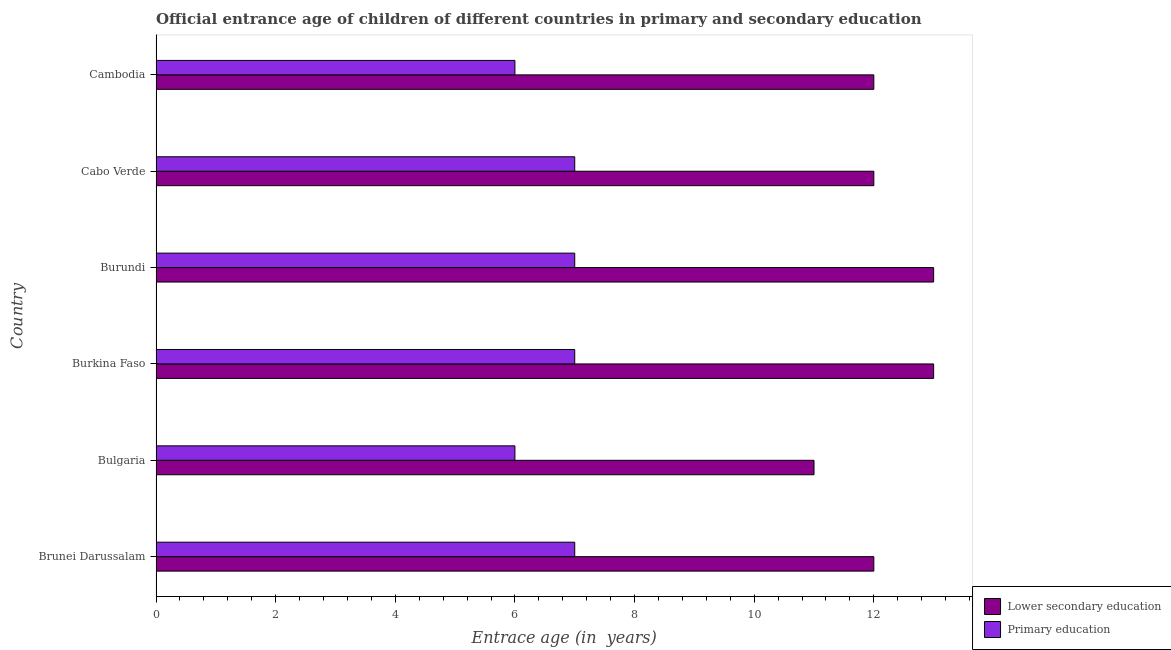How many groups of bars are there?
Ensure brevity in your answer.  6. Are the number of bars on each tick of the Y-axis equal?
Provide a short and direct response. Yes. How many bars are there on the 2nd tick from the bottom?
Offer a very short reply. 2. What is the label of the 3rd group of bars from the top?
Your response must be concise. Burundi. What is the entrance age of children in lower secondary education in Cabo Verde?
Your answer should be compact. 12. Across all countries, what is the maximum entrance age of chiildren in primary education?
Make the answer very short. 7. In which country was the entrance age of children in lower secondary education maximum?
Ensure brevity in your answer.  Burkina Faso. In which country was the entrance age of children in lower secondary education minimum?
Offer a terse response. Bulgaria. What is the total entrance age of children in lower secondary education in the graph?
Provide a short and direct response. 73. What is the difference between the entrance age of children in lower secondary education in Burundi and the entrance age of chiildren in primary education in Brunei Darussalam?
Provide a short and direct response. 6. What is the average entrance age of chiildren in primary education per country?
Keep it short and to the point. 6.67. What is the ratio of the entrance age of chiildren in primary education in Burkina Faso to that in Cambodia?
Provide a succinct answer. 1.17. Is the entrance age of children in lower secondary education in Burkina Faso less than that in Cabo Verde?
Give a very brief answer. No. Is the difference between the entrance age of chiildren in primary education in Burundi and Cabo Verde greater than the difference between the entrance age of children in lower secondary education in Burundi and Cabo Verde?
Your answer should be very brief. No. What is the difference between the highest and the lowest entrance age of chiildren in primary education?
Provide a succinct answer. 1. Is the sum of the entrance age of chiildren in primary education in Brunei Darussalam and Bulgaria greater than the maximum entrance age of children in lower secondary education across all countries?
Your answer should be very brief. No. What does the 1st bar from the bottom in Cambodia represents?
Keep it short and to the point. Lower secondary education. Are all the bars in the graph horizontal?
Ensure brevity in your answer.  Yes. Where does the legend appear in the graph?
Give a very brief answer. Bottom right. What is the title of the graph?
Keep it short and to the point. Official entrance age of children of different countries in primary and secondary education. Does "Non-solid fuel" appear as one of the legend labels in the graph?
Offer a terse response. No. What is the label or title of the X-axis?
Provide a short and direct response. Entrace age (in  years). What is the Entrace age (in  years) of Primary education in Brunei Darussalam?
Provide a short and direct response. 7. What is the Entrace age (in  years) of Lower secondary education in Burundi?
Make the answer very short. 13. What is the Entrace age (in  years) of Primary education in Burundi?
Ensure brevity in your answer.  7. What is the Entrace age (in  years) of Lower secondary education in Cabo Verde?
Offer a very short reply. 12. What is the Entrace age (in  years) of Primary education in Cabo Verde?
Offer a very short reply. 7. What is the Entrace age (in  years) in Lower secondary education in Cambodia?
Provide a succinct answer. 12. What is the Entrace age (in  years) in Primary education in Cambodia?
Provide a short and direct response. 6. Across all countries, what is the minimum Entrace age (in  years) of Lower secondary education?
Keep it short and to the point. 11. Across all countries, what is the minimum Entrace age (in  years) in Primary education?
Your answer should be very brief. 6. What is the total Entrace age (in  years) in Primary education in the graph?
Provide a succinct answer. 40. What is the difference between the Entrace age (in  years) of Lower secondary education in Brunei Darussalam and that in Burkina Faso?
Your answer should be compact. -1. What is the difference between the Entrace age (in  years) in Lower secondary education in Brunei Darussalam and that in Burundi?
Make the answer very short. -1. What is the difference between the Entrace age (in  years) in Primary education in Brunei Darussalam and that in Burundi?
Your answer should be very brief. 0. What is the difference between the Entrace age (in  years) of Lower secondary education in Brunei Darussalam and that in Cambodia?
Ensure brevity in your answer.  0. What is the difference between the Entrace age (in  years) in Lower secondary education in Bulgaria and that in Burundi?
Make the answer very short. -2. What is the difference between the Entrace age (in  years) in Primary education in Bulgaria and that in Burundi?
Offer a very short reply. -1. What is the difference between the Entrace age (in  years) in Lower secondary education in Burkina Faso and that in Cabo Verde?
Your answer should be compact. 1. What is the difference between the Entrace age (in  years) in Primary education in Burkina Faso and that in Cambodia?
Offer a terse response. 1. What is the difference between the Entrace age (in  years) of Primary education in Burundi and that in Cabo Verde?
Your answer should be very brief. 0. What is the difference between the Entrace age (in  years) in Lower secondary education in Burundi and that in Cambodia?
Your answer should be very brief. 1. What is the difference between the Entrace age (in  years) in Lower secondary education in Cabo Verde and that in Cambodia?
Provide a short and direct response. 0. What is the difference between the Entrace age (in  years) of Primary education in Cabo Verde and that in Cambodia?
Provide a short and direct response. 1. What is the difference between the Entrace age (in  years) of Lower secondary education in Brunei Darussalam and the Entrace age (in  years) of Primary education in Cabo Verde?
Offer a very short reply. 5. What is the difference between the Entrace age (in  years) in Lower secondary education in Brunei Darussalam and the Entrace age (in  years) in Primary education in Cambodia?
Your response must be concise. 6. What is the difference between the Entrace age (in  years) of Lower secondary education in Bulgaria and the Entrace age (in  years) of Primary education in Burkina Faso?
Provide a short and direct response. 4. What is the difference between the Entrace age (in  years) in Lower secondary education in Bulgaria and the Entrace age (in  years) in Primary education in Cabo Verde?
Provide a succinct answer. 4. What is the difference between the Entrace age (in  years) in Lower secondary education in Bulgaria and the Entrace age (in  years) in Primary education in Cambodia?
Give a very brief answer. 5. What is the difference between the Entrace age (in  years) in Lower secondary education in Burkina Faso and the Entrace age (in  years) in Primary education in Cambodia?
Give a very brief answer. 7. What is the average Entrace age (in  years) in Lower secondary education per country?
Your answer should be compact. 12.17. What is the average Entrace age (in  years) of Primary education per country?
Ensure brevity in your answer.  6.67. What is the difference between the Entrace age (in  years) in Lower secondary education and Entrace age (in  years) in Primary education in Burkina Faso?
Make the answer very short. 6. What is the ratio of the Entrace age (in  years) of Primary education in Brunei Darussalam to that in Bulgaria?
Ensure brevity in your answer.  1.17. What is the ratio of the Entrace age (in  years) of Primary education in Brunei Darussalam to that in Burkina Faso?
Provide a short and direct response. 1. What is the ratio of the Entrace age (in  years) of Lower secondary education in Brunei Darussalam to that in Burundi?
Keep it short and to the point. 0.92. What is the ratio of the Entrace age (in  years) of Lower secondary education in Bulgaria to that in Burkina Faso?
Provide a short and direct response. 0.85. What is the ratio of the Entrace age (in  years) in Lower secondary education in Bulgaria to that in Burundi?
Your answer should be very brief. 0.85. What is the ratio of the Entrace age (in  years) of Primary education in Bulgaria to that in Burundi?
Your response must be concise. 0.86. What is the ratio of the Entrace age (in  years) in Lower secondary education in Bulgaria to that in Cabo Verde?
Offer a very short reply. 0.92. What is the ratio of the Entrace age (in  years) of Primary education in Burkina Faso to that in Burundi?
Give a very brief answer. 1. What is the ratio of the Entrace age (in  years) of Lower secondary education in Burkina Faso to that in Cabo Verde?
Provide a succinct answer. 1.08. What is the ratio of the Entrace age (in  years) in Primary education in Burkina Faso to that in Cabo Verde?
Provide a succinct answer. 1. What is the ratio of the Entrace age (in  years) of Lower secondary education in Burkina Faso to that in Cambodia?
Your response must be concise. 1.08. What is the ratio of the Entrace age (in  years) in Lower secondary education in Burundi to that in Cambodia?
Offer a terse response. 1.08. What is the difference between the highest and the second highest Entrace age (in  years) of Primary education?
Provide a succinct answer. 0. 